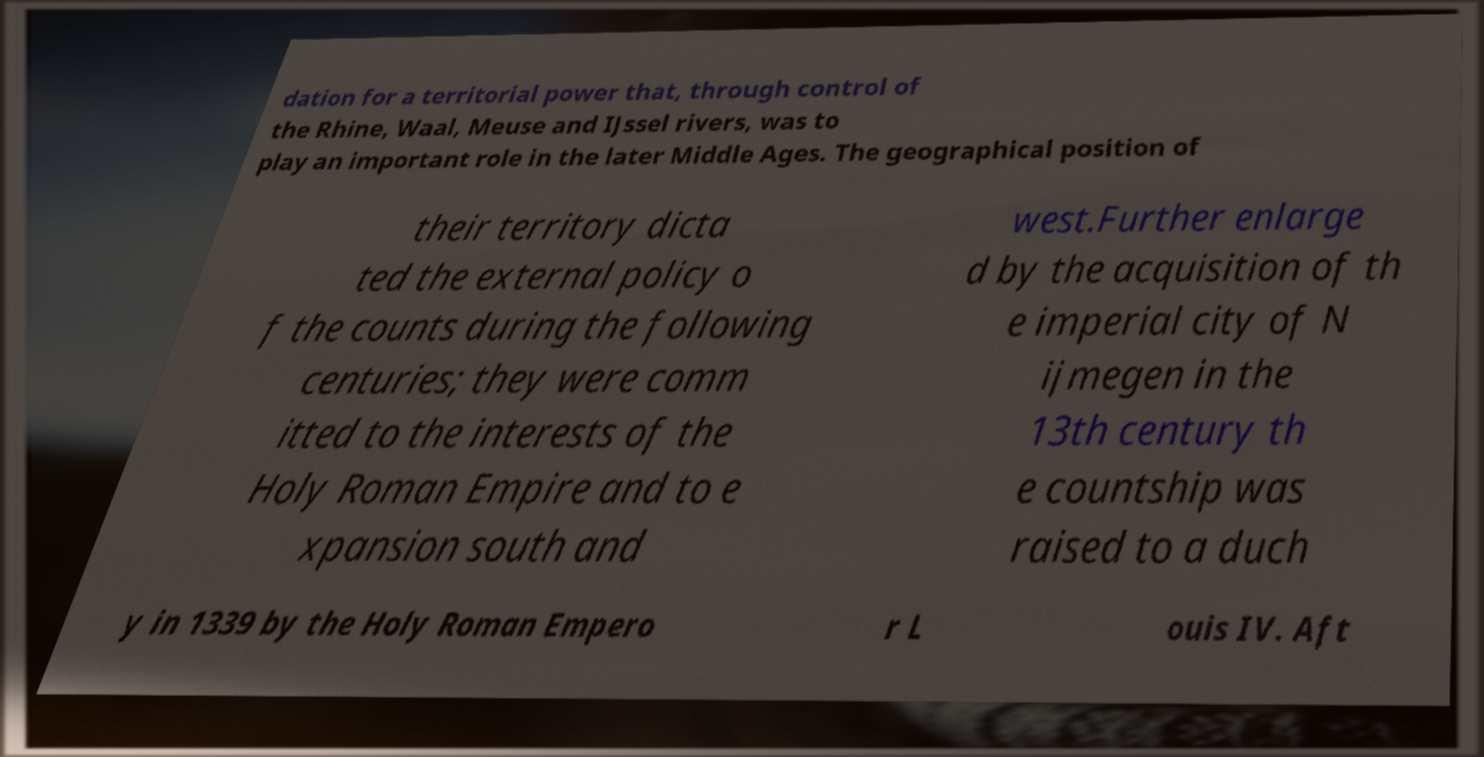Could you extract and type out the text from this image? dation for a territorial power that, through control of the Rhine, Waal, Meuse and IJssel rivers, was to play an important role in the later Middle Ages. The geographical position of their territory dicta ted the external policy o f the counts during the following centuries; they were comm itted to the interests of the Holy Roman Empire and to e xpansion south and west.Further enlarge d by the acquisition of th e imperial city of N ijmegen in the 13th century th e countship was raised to a duch y in 1339 by the Holy Roman Empero r L ouis IV. Aft 